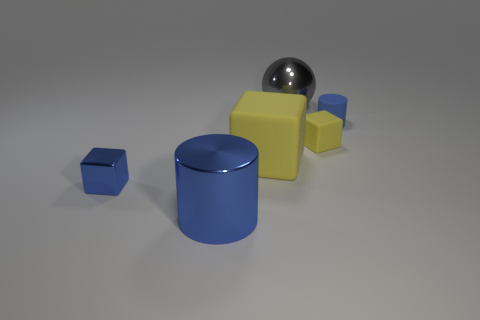Subtract all metallic cubes. How many cubes are left? 2 Subtract all blue cubes. How many cubes are left? 2 Add 4 large brown things. How many objects exist? 10 Subtract all cylinders. How many objects are left? 4 Subtract 1 cubes. How many cubes are left? 2 Subtract all brown spheres. How many yellow blocks are left? 2 Add 1 tiny yellow matte blocks. How many tiny yellow matte blocks exist? 2 Subtract 0 brown cylinders. How many objects are left? 6 Subtract all green cylinders. Subtract all cyan cubes. How many cylinders are left? 2 Subtract all big yellow rubber blocks. Subtract all matte objects. How many objects are left? 2 